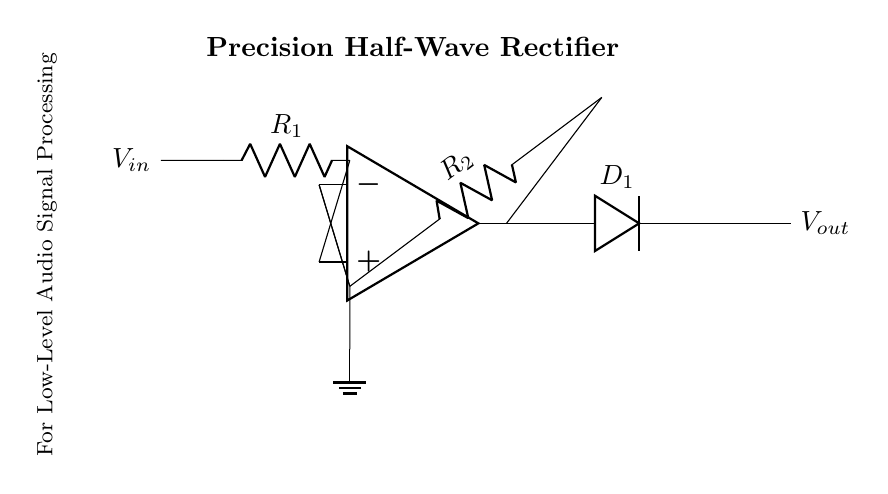What is the role of the op-amp in this circuit? The op-amp serves as a voltage amplifier, allowing for the detection of low-level audio signals and ensuring that the output is a rectified version of the input signal.
Answer: Voltage amplifier What type of diode is used in this circuit? The circuit uses a single diode for rectification, as indicated by the labeling of D1.
Answer: Diode What is the function of resistor R1? Resistor R1 helps set the gain for the input signal, which is crucial for amplifying low-level audio signals before they are rectified.
Answer: Set gain What is the expected output voltage type? The output voltage is expected to be positive only due to the half-wave rectification nature of the circuit, allowing only positive portions of the input signal to pass through.
Answer: Positive only How does this circuit process audio signals? The circuit amplifies the low-level audio input signals and then rectifies them to create a waveform representative of the audio signal's envelope, which can be further analyzed or measured.
Answer: Amplifies and rectifies Which component provides the feedback in this circuit? Resistor R2 is the component used for feedback in the configuration, connecting the output of the op-amp back to its inverting input terminal.
Answer: Resistor R2 